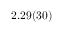Convert formula to latex. <formula><loc_0><loc_0><loc_500><loc_500>2 . 2 9 ( 3 0 )</formula> 